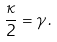<formula> <loc_0><loc_0><loc_500><loc_500>\frac { \kappa } { 2 } = \gamma \, .</formula> 